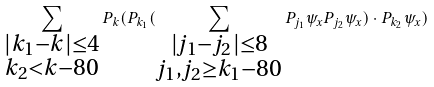<formula> <loc_0><loc_0><loc_500><loc_500>\sum _ { \substack { | k _ { 1 } - k | \leq 4 \\ k _ { 2 } < k - 8 0 } } P _ { k } ( P _ { k _ { 1 } } ( \sum _ { \substack { | j _ { 1 } - j _ { 2 } | \leq 8 \\ j _ { 1 } , j _ { 2 } \geq k _ { 1 } - 8 0 } } P _ { j _ { 1 } } \psi _ { x } P _ { j _ { 2 } } \psi _ { x } ) \cdot P _ { k _ { 2 } } \psi _ { x } )</formula> 